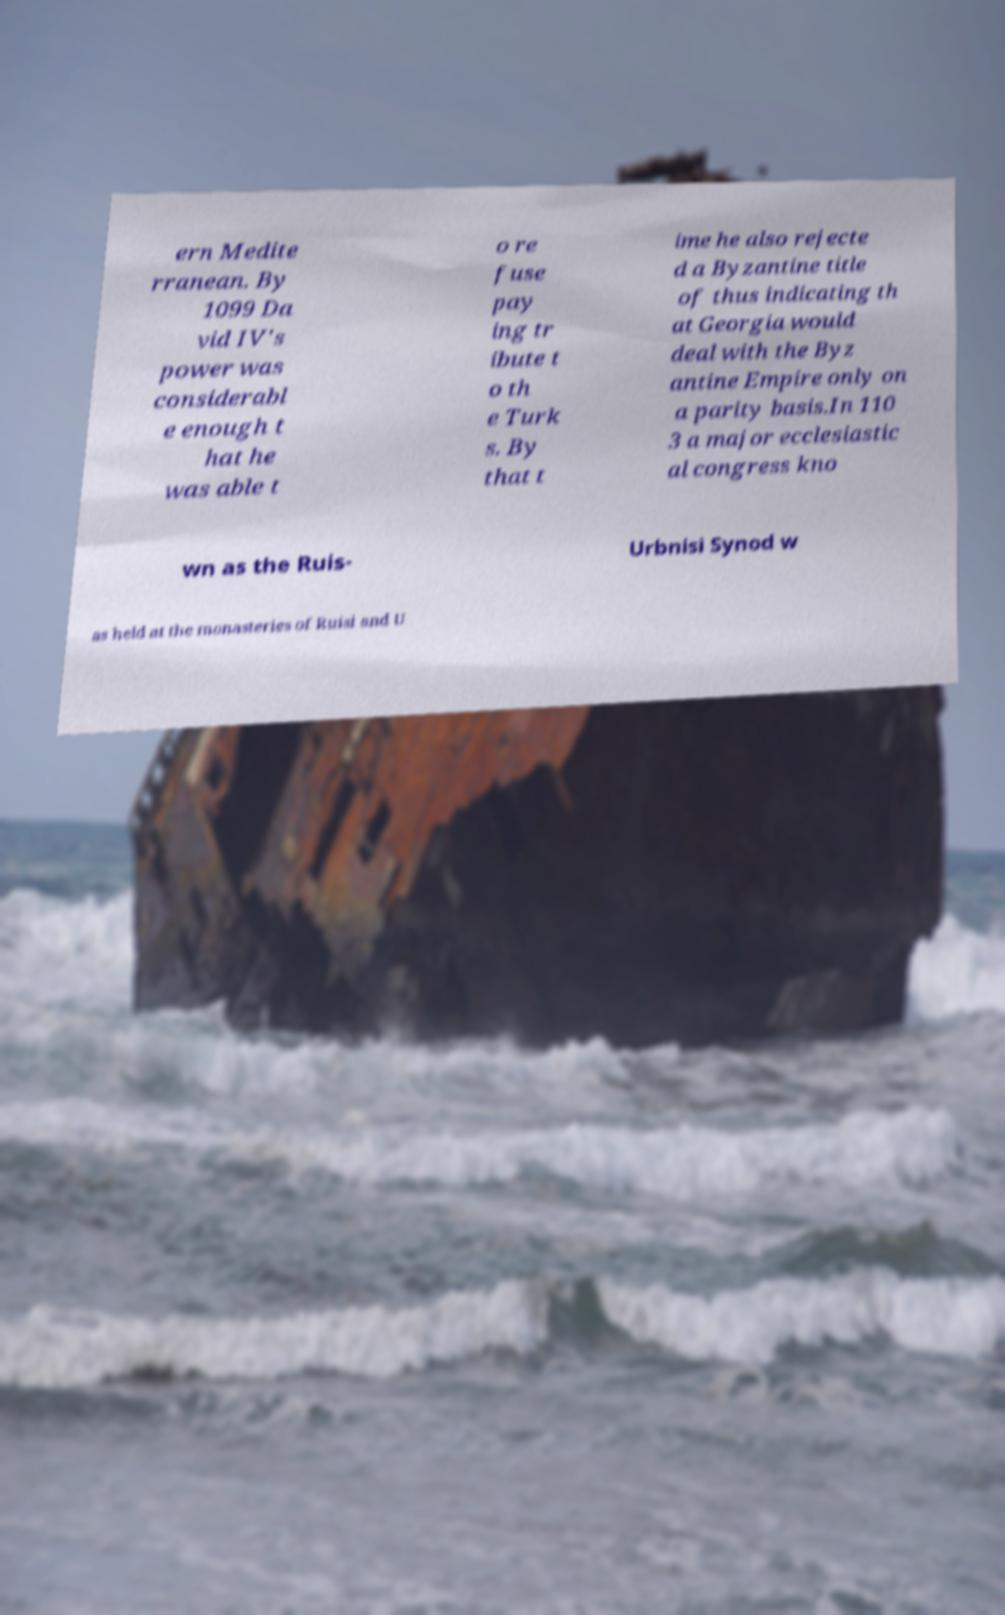Could you extract and type out the text from this image? ern Medite rranean. By 1099 Da vid IV's power was considerabl e enough t hat he was able t o re fuse pay ing tr ibute t o th e Turk s. By that t ime he also rejecte d a Byzantine title of thus indicating th at Georgia would deal with the Byz antine Empire only on a parity basis.In 110 3 a major ecclesiastic al congress kno wn as the Ruis- Urbnisi Synod w as held at the monasteries of Ruisi and U 